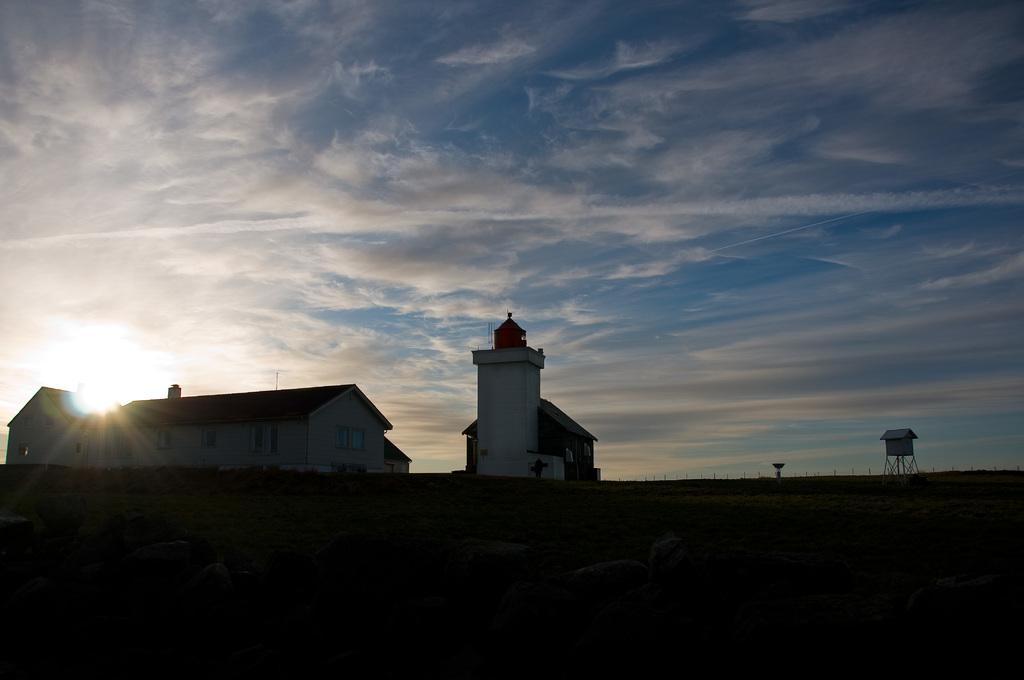What is the main structure in the center of the image? There is a tower in the center of the image. Are there any other structures near the tower? Yes, there are sheds near the tower. What can be seen in the background of the image? The sky is visible in the background of the image. What type of finger can be seen holding the apparatus in the image? There is no finger or apparatus present in the image. What kind of breakfast is being served in the image? There is no breakfast being served in the image. 